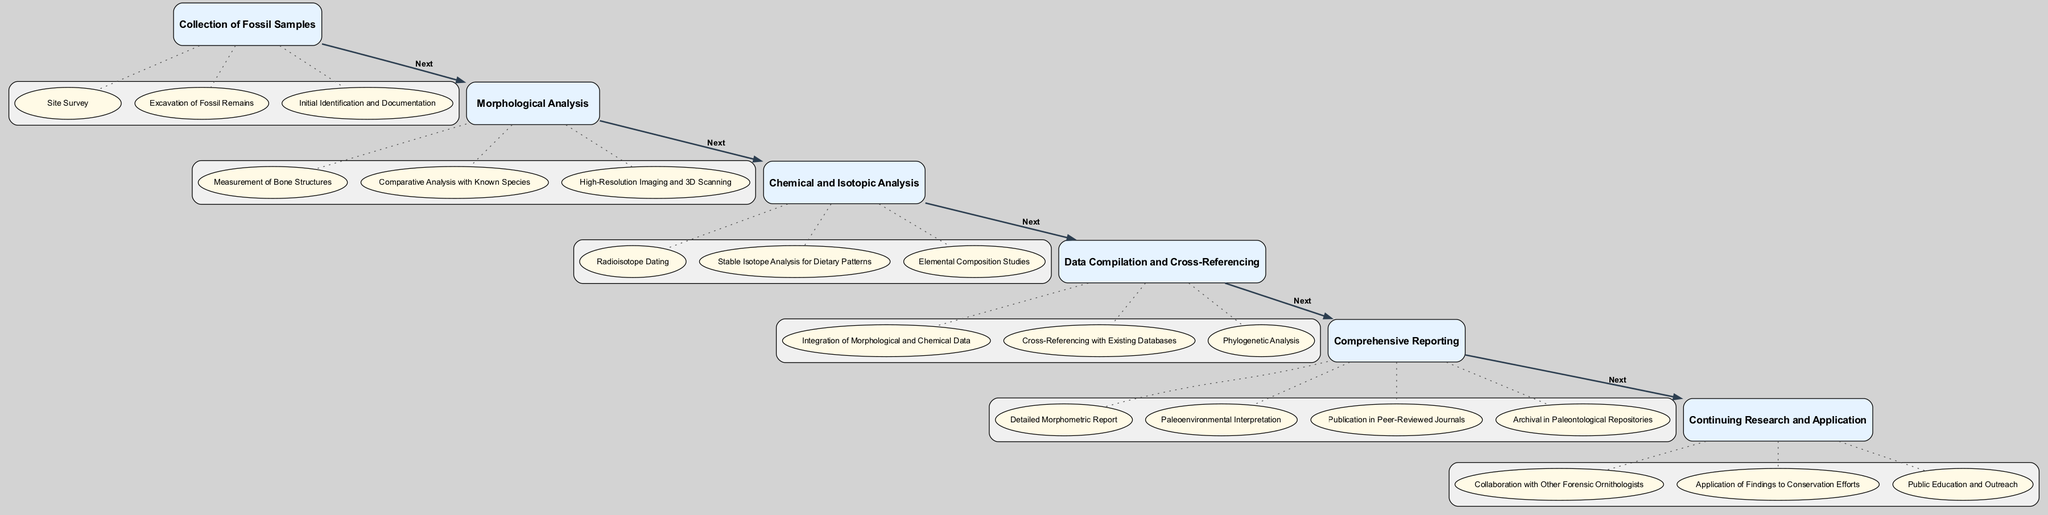What is the first step in the clinical pathway? The initial step is labeled "Collection of Fossil Samples". This can be found in the "InitialAssessment" section of the diagram.
Answer: Collection of Fossil Samples How many actions are listed under "Morphological Analysis"? The "Morphological Analysis" step has three distinct actions: "Measurement of Bone Structures", "Comparative Analysis with Known Species", and "High-Resolution Imaging and 3D Scanning".
Answer: 3 What is the last step in the clinical pathway? The final step is the "Comprehensive Reporting". This is represented as the last node in the sequence of the diagram.
Answer: Comprehensive Reporting Which testing involves Radioisotope Dating? "Chemical and Isotopic Analysis" includes the action "Radioisotope Dating", indicating it is part of the ancillary testing procedures.
Answer: Chemical and Isotopic Analysis How are the steps connected in the pathway? Each step is connected in a sequential manner with arrows labeled "Next" that lead from one step to the following step, creating a linear pathway.
Answer: Sequentially What type of analysis occurs after "Morphological Analysis"? The step that follows "Morphological Analysis" is "Chemical and Isotopic Analysis". This is determined by the connections drawn between the steps in the pathway.
Answer: Chemical and Isotopic Analysis Which actions are part of the "Data Compilation and Cross-Referencing"? This step includes "Integration of Morphological and Chemical Data," "Cross-Referencing with Existing Databases," and "Phylogenetic Analysis," which are its associated actions.
Answer: Integration of Morphological and Chemical Data, Cross-Referencing with Existing Databases, Phylogenetic Analysis What is the purpose of the "Final Report" step? The "Final Report" step includes creating a "Detailed Morphometric Report", "Paleoenvironmental Interpretation", "Publication in Peer-Reviewed Journals", and archival in repositories, indicating its purpose of summarizing findings.
Answer: Comprehensive summary of findings What follows after "Comprehensive Reporting"? "Comprehensive Reporting" is the final step in the pathway, so there are no steps following it according to the structure of the diagram.
Answer: None 